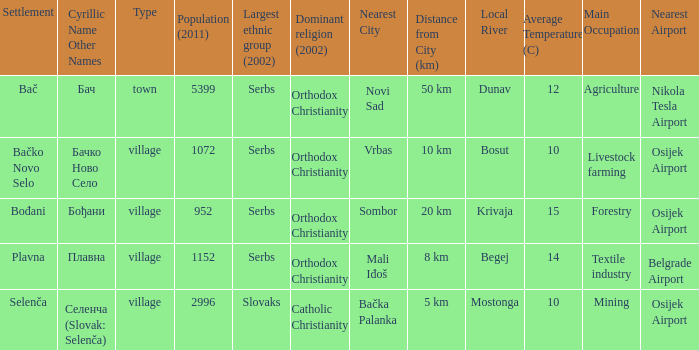What is the second way of writting плавна. Plavna. 